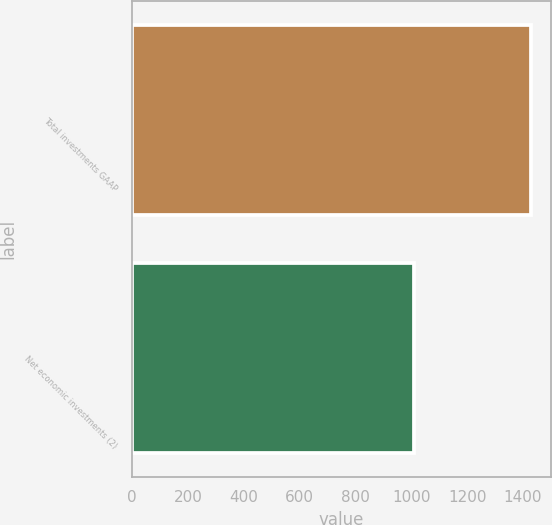<chart> <loc_0><loc_0><loc_500><loc_500><bar_chart><fcel>Total investments GAAP<fcel>Net economic investments (2)<nl><fcel>1429<fcel>1011<nl></chart> 